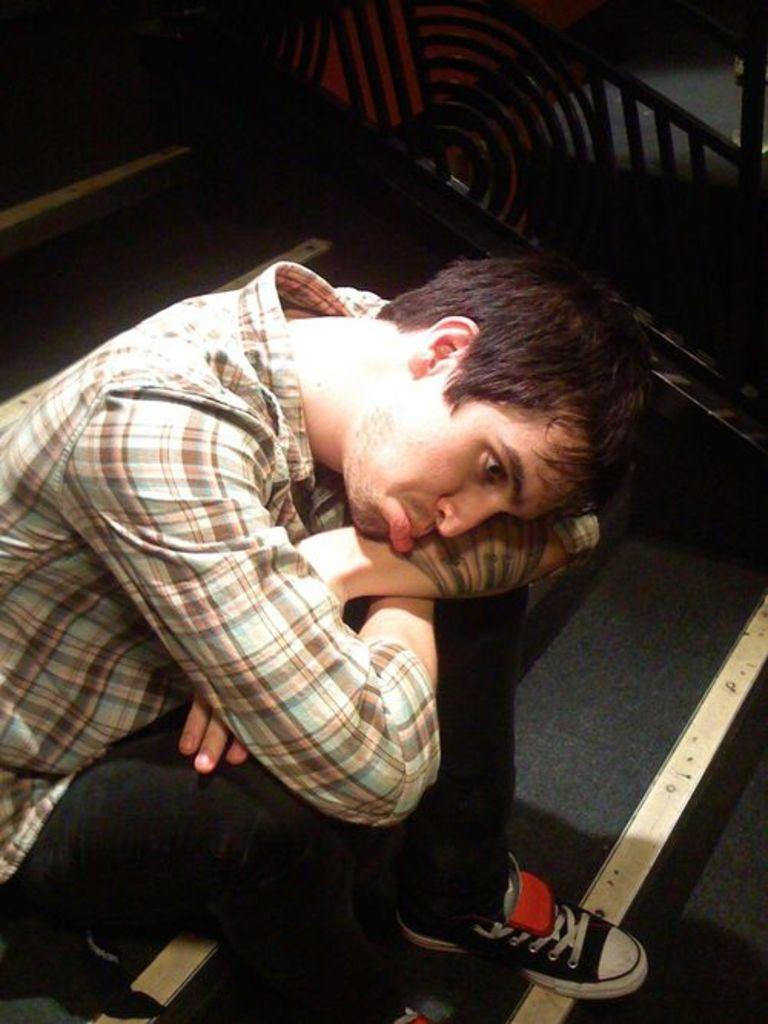What is the person in the image doing? The person is sitting on a staircase in the image. How does the person appear to be feeling? The person is making a sad face. What is located beside the person? There is a railing present beside the person. What shape does the person's belief system take in the image? The image does not provide any information about the person's belief system, so it cannot be determined from the image. 